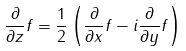Convert formula to latex. <formula><loc_0><loc_0><loc_500><loc_500>\frac { \partial } { \partial z } f = \frac { 1 } { 2 } \left ( \frac { \partial } { \partial x } f - i \frac { \partial } { \partial y } f \right )</formula> 